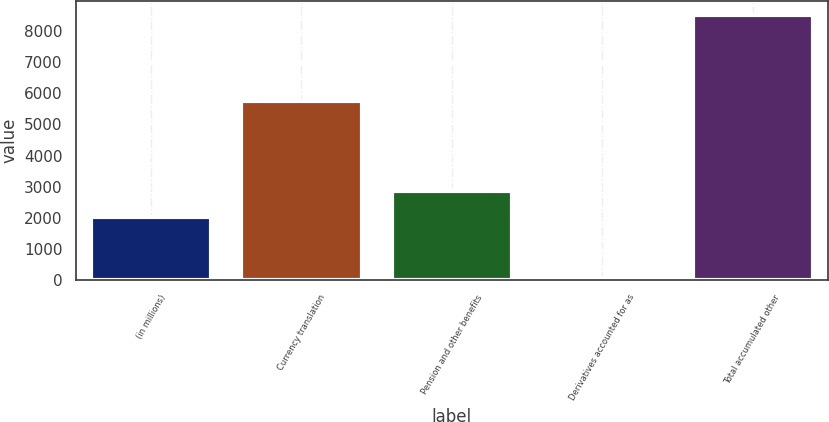Convert chart to OTSL. <chart><loc_0><loc_0><loc_500><loc_500><bar_chart><fcel>(in millions)<fcel>Currency translation<fcel>Pension and other benefits<fcel>Derivatives accounted for as<fcel>Total accumulated other<nl><fcel>2017<fcel>5761<fcel>2866.3<fcel>42<fcel>8535<nl></chart> 